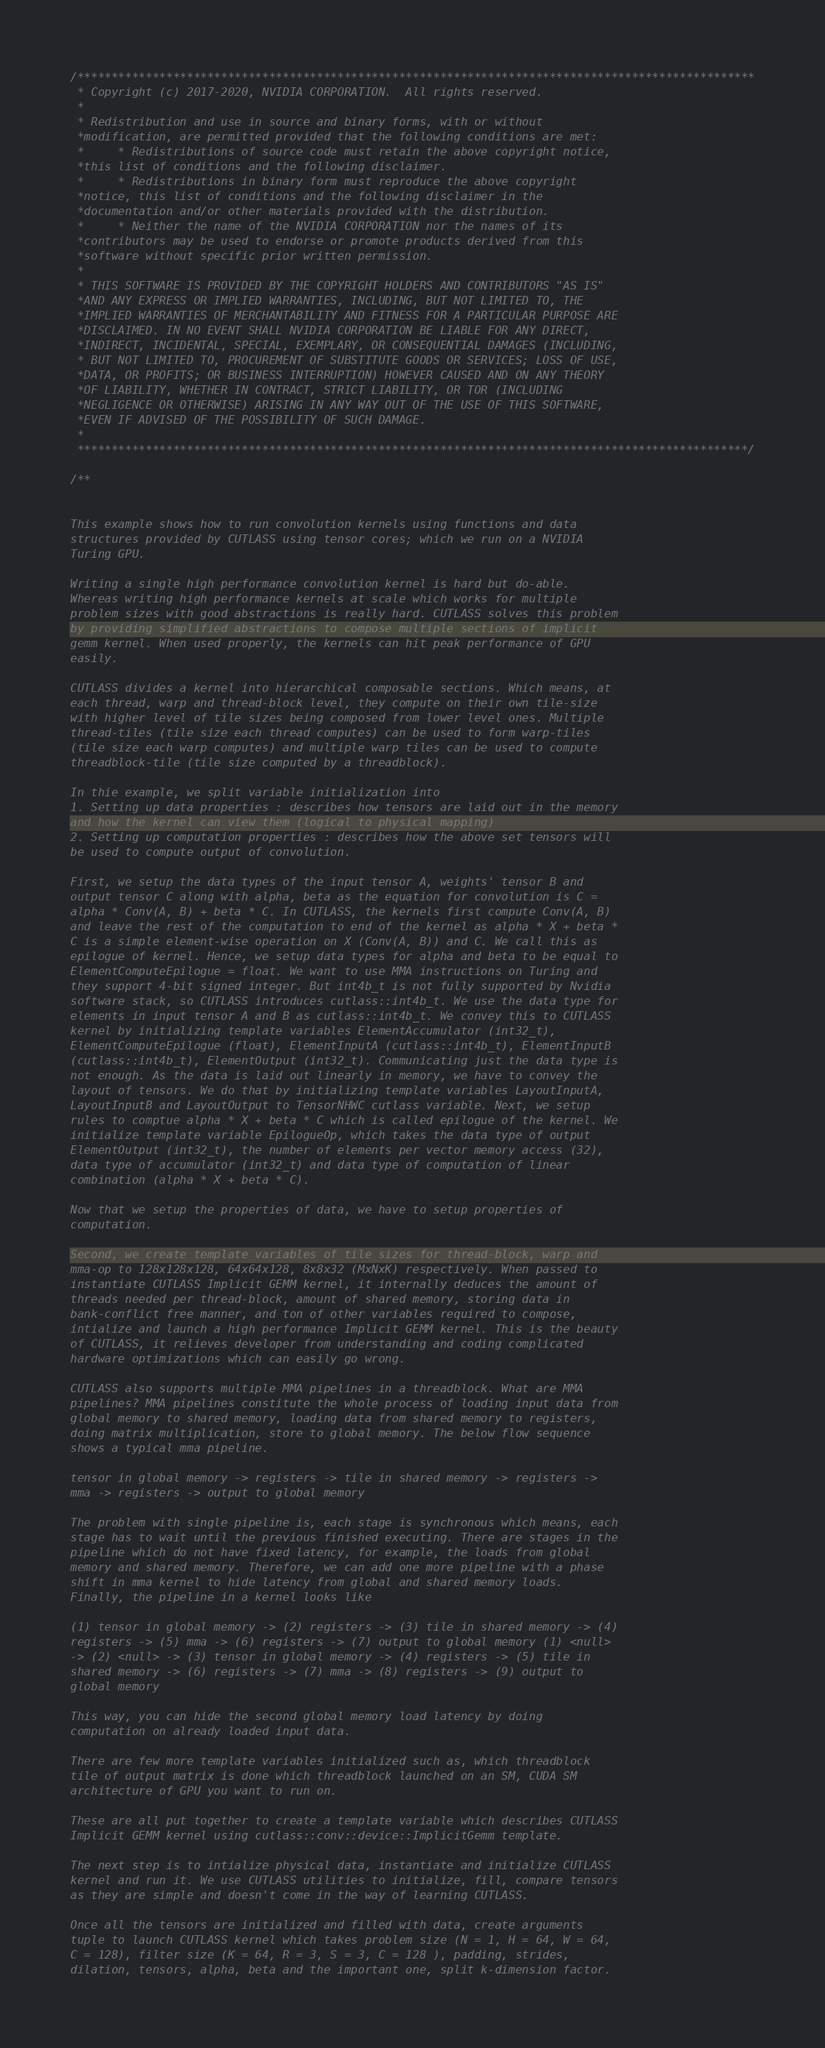<code> <loc_0><loc_0><loc_500><loc_500><_Cuda_>/***************************************************************************************************
 * Copyright (c) 2017-2020, NVIDIA CORPORATION.  All rights reserved.
 *
 * Redistribution and use in source and binary forms, with or without
 *modification, are permitted provided that the following conditions are met:
 *     * Redistributions of source code must retain the above copyright notice,
 *this list of conditions and the following disclaimer.
 *     * Redistributions in binary form must reproduce the above copyright
 *notice, this list of conditions and the following disclaimer in the
 *documentation and/or other materials provided with the distribution.
 *     * Neither the name of the NVIDIA CORPORATION nor the names of its
 *contributors may be used to endorse or promote products derived from this
 *software without specific prior written permission.
 *
 * THIS SOFTWARE IS PROVIDED BY THE COPYRIGHT HOLDERS AND CONTRIBUTORS "AS IS"
 *AND ANY EXPRESS OR IMPLIED WARRANTIES, INCLUDING, BUT NOT LIMITED TO, THE
 *IMPLIED WARRANTIES OF MERCHANTABILITY AND FITNESS FOR A PARTICULAR PURPOSE ARE
 *DISCLAIMED. IN NO EVENT SHALL NVIDIA CORPORATION BE LIABLE FOR ANY DIRECT,
 *INDIRECT, INCIDENTAL, SPECIAL, EXEMPLARY, OR CONSEQUENTIAL DAMAGES (INCLUDING,
 * BUT NOT LIMITED TO, PROCUREMENT OF SUBSTITUTE GOODS OR SERVICES; LOSS OF USE,
 *DATA, OR PROFITS; OR BUSINESS INTERRUPTION) HOWEVER CAUSED AND ON ANY THEORY
 *OF LIABILITY, WHETHER IN CONTRACT, STRICT LIABILITY, OR TOR (INCLUDING
 *NEGLIGENCE OR OTHERWISE) ARISING IN ANY WAY OUT OF THE USE OF THIS SOFTWARE,
 *EVEN IF ADVISED OF THE POSSIBILITY OF SUCH DAMAGE.
 *
 **************************************************************************************************/

/**


This example shows how to run convolution kernels using functions and data
structures provided by CUTLASS using tensor cores; which we run on a NVIDIA
Turing GPU.

Writing a single high performance convolution kernel is hard but do-able.
Whereas writing high performance kernels at scale which works for multiple
problem sizes with good abstractions is really hard. CUTLASS solves this problem
by providing simplified abstractions to compose multiple sections of implicit
gemm kernel. When used properly, the kernels can hit peak performance of GPU
easily.

CUTLASS divides a kernel into hierarchical composable sections. Which means, at
each thread, warp and thread-block level, they compute on their own tile-size
with higher level of tile sizes being composed from lower level ones. Multiple
thread-tiles (tile size each thread computes) can be used to form warp-tiles
(tile size each warp computes) and multiple warp tiles can be used to compute
threadblock-tile (tile size computed by a threadblock).

In thie example, we split variable initialization into
1. Setting up data properties : describes how tensors are laid out in the memory
and how the kernel can view them (logical to physical mapping)
2. Setting up computation properties : describes how the above set tensors will
be used to compute output of convolution.

First, we setup the data types of the input tensor A, weights' tensor B and
output tensor C along with alpha, beta as the equation for convolution is C =
alpha * Conv(A, B) + beta * C. In CUTLASS, the kernels first compute Conv(A, B)
and leave the rest of the computation to end of the kernel as alpha * X + beta *
C is a simple element-wise operation on X (Conv(A, B)) and C. We call this as
epilogue of kernel. Hence, we setup data types for alpha and beta to be equal to
ElementComputeEpilogue = float. We want to use MMA instructions on Turing and
they support 4-bit signed integer. But int4b_t is not fully supported by Nvidia
software stack, so CUTLASS introduces cutlass::int4b_t. We use the data type for
elements in input tensor A and B as cutlass::int4b_t. We convey this to CUTLASS
kernel by initializing template variables ElementAccumulator (int32_t),
ElementComputeEpilogue (float), ElementInputA (cutlass::int4b_t), ElementInputB
(cutlass::int4b_t), ElementOutput (int32_t). Communicating just the data type is
not enough. As the data is laid out linearly in memory, we have to convey the
layout of tensors. We do that by initializing template variables LayoutInputA,
LayoutInputB and LayoutOutput to TensorNHWC cutlass variable. Next, we setup
rules to comptue alpha * X + beta * C which is called epilogue of the kernel. We
initialize template variable EpilogueOp, which takes the data type of output
ElementOutput (int32_t), the number of elements per vector memory access (32),
data type of accumulator (int32_t) and data type of computation of linear
combination (alpha * X + beta * C).

Now that we setup the properties of data, we have to setup properties of
computation.

Second, we create template variables of tile sizes for thread-block, warp and
mma-op to 128x128x128, 64x64x128, 8x8x32 (MxNxK) respectively. When passed to
instantiate CUTLASS Implicit GEMM kernel, it internally deduces the amount of
threads needed per thread-block, amount of shared memory, storing data in
bank-conflict free manner, and ton of other variables required to compose,
intialize and launch a high performance Implicit GEMM kernel. This is the beauty
of CUTLASS, it relieves developer from understanding and coding complicated
hardware optimizations which can easily go wrong.

CUTLASS also supports multiple MMA pipelines in a threadblock. What are MMA
pipelines? MMA pipelines constitute the whole process of loading input data from
global memory to shared memory, loading data from shared memory to registers,
doing matrix multiplication, store to global memory. The below flow sequence
shows a typical mma pipeline.

tensor in global memory -> registers -> tile in shared memory -> registers ->
mma -> registers -> output to global memory

The problem with single pipeline is, each stage is synchronous which means, each
stage has to wait until the previous finished executing. There are stages in the
pipeline which do not have fixed latency, for example, the loads from global
memory and shared memory. Therefore, we can add one more pipeline with a phase
shift in mma kernel to hide latency from global and shared memory loads.
Finally, the pipeline in a kernel looks like

(1) tensor in global memory -> (2) registers -> (3) tile in shared memory -> (4)
registers -> (5) mma -> (6) registers -> (7) output to global memory (1) <null>
-> (2) <null> -> (3) tensor in global memory -> (4) registers -> (5) tile in
shared memory -> (6) registers -> (7) mma -> (8) registers -> (9) output to
global memory

This way, you can hide the second global memory load latency by doing
computation on already loaded input data.

There are few more template variables initialized such as, which threadblock
tile of output matrix is done which threadblock launched on an SM, CUDA SM
architecture of GPU you want to run on.

These are all put together to create a template variable which describes CUTLASS
Implicit GEMM kernel using cutlass::conv::device::ImplicitGemm template.

The next step is to intialize physical data, instantiate and initialize CUTLASS
kernel and run it. We use CUTLASS utilities to initialize, fill, compare tensors
as they are simple and doesn't come in the way of learning CUTLASS.

Once all the tensors are initialized and filled with data, create arguments
tuple to launch CUTLASS kernel which takes problem size (N = 1, H = 64, W = 64,
C = 128), filter size (K = 64, R = 3, S = 3, C = 128 ), padding, strides,
dilation, tensors, alpha, beta and the important one, split k-dimension factor.</code> 